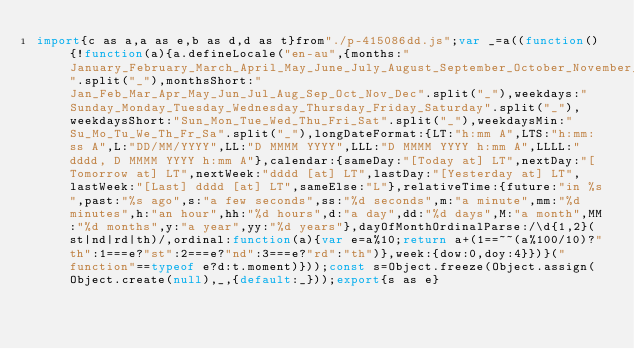Convert code to text. <code><loc_0><loc_0><loc_500><loc_500><_JavaScript_>import{c as a,a as e,b as d,d as t}from"./p-415086dd.js";var _=a((function(){!function(a){a.defineLocale("en-au",{months:"January_February_March_April_May_June_July_August_September_October_November_December".split("_"),monthsShort:"Jan_Feb_Mar_Apr_May_Jun_Jul_Aug_Sep_Oct_Nov_Dec".split("_"),weekdays:"Sunday_Monday_Tuesday_Wednesday_Thursday_Friday_Saturday".split("_"),weekdaysShort:"Sun_Mon_Tue_Wed_Thu_Fri_Sat".split("_"),weekdaysMin:"Su_Mo_Tu_We_Th_Fr_Sa".split("_"),longDateFormat:{LT:"h:mm A",LTS:"h:mm:ss A",L:"DD/MM/YYYY",LL:"D MMMM YYYY",LLL:"D MMMM YYYY h:mm A",LLLL:"dddd, D MMMM YYYY h:mm A"},calendar:{sameDay:"[Today at] LT",nextDay:"[Tomorrow at] LT",nextWeek:"dddd [at] LT",lastDay:"[Yesterday at] LT",lastWeek:"[Last] dddd [at] LT",sameElse:"L"},relativeTime:{future:"in %s",past:"%s ago",s:"a few seconds",ss:"%d seconds",m:"a minute",mm:"%d minutes",h:"an hour",hh:"%d hours",d:"a day",dd:"%d days",M:"a month",MM:"%d months",y:"a year",yy:"%d years"},dayOfMonthOrdinalParse:/\d{1,2}(st|nd|rd|th)/,ordinal:function(a){var e=a%10;return a+(1==~~(a%100/10)?"th":1===e?"st":2===e?"nd":3===e?"rd":"th")},week:{dow:0,doy:4}})}("function"==typeof e?d:t.moment)}));const s=Object.freeze(Object.assign(Object.create(null),_,{default:_}));export{s as e}</code> 